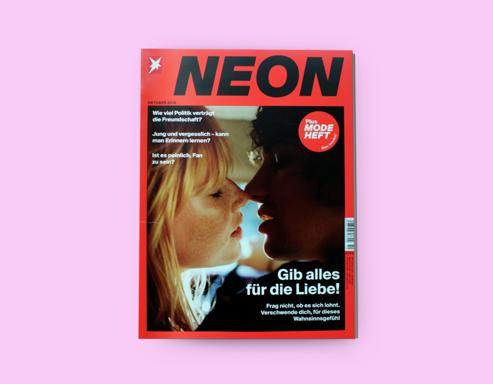What is the title of the magazine cover? The magazine cover is titled 'NEON.' This title is prominently displayed at the top of the cover in large, bold lettering which grabs the reader's attention. 'NEON' suggests a focus on vivid, striking content that stands out, much like the neon lights it is named after. 